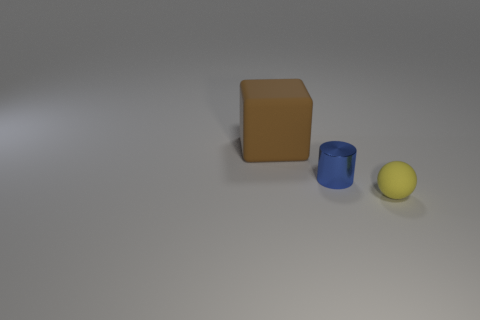Subtract all red cylinders. How many blue blocks are left? 0 Subtract all small yellow matte spheres. Subtract all small objects. How many objects are left? 0 Add 2 tiny yellow things. How many tiny yellow things are left? 3 Add 2 tiny red matte blocks. How many tiny red matte blocks exist? 2 Add 3 small green things. How many objects exist? 6 Subtract 1 blue cylinders. How many objects are left? 2 Subtract all cubes. How many objects are left? 2 